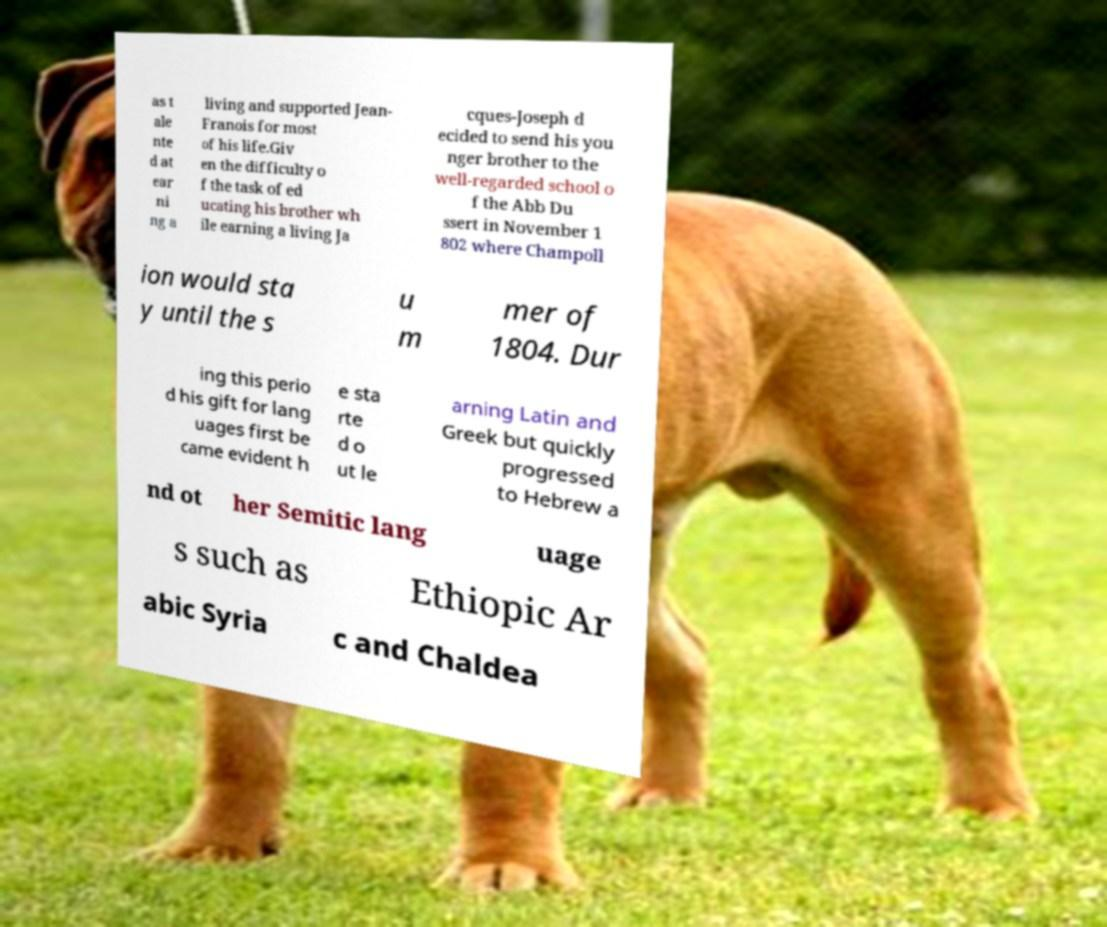What messages or text are displayed in this image? I need them in a readable, typed format. as t ale nte d at ear ni ng a living and supported Jean- Franois for most of his life.Giv en the difficulty o f the task of ed ucating his brother wh ile earning a living Ja cques-Joseph d ecided to send his you nger brother to the well-regarded school o f the Abb Du ssert in November 1 802 where Champoll ion would sta y until the s u m mer of 1804. Dur ing this perio d his gift for lang uages first be came evident h e sta rte d o ut le arning Latin and Greek but quickly progressed to Hebrew a nd ot her Semitic lang uage s such as Ethiopic Ar abic Syria c and Chaldea 